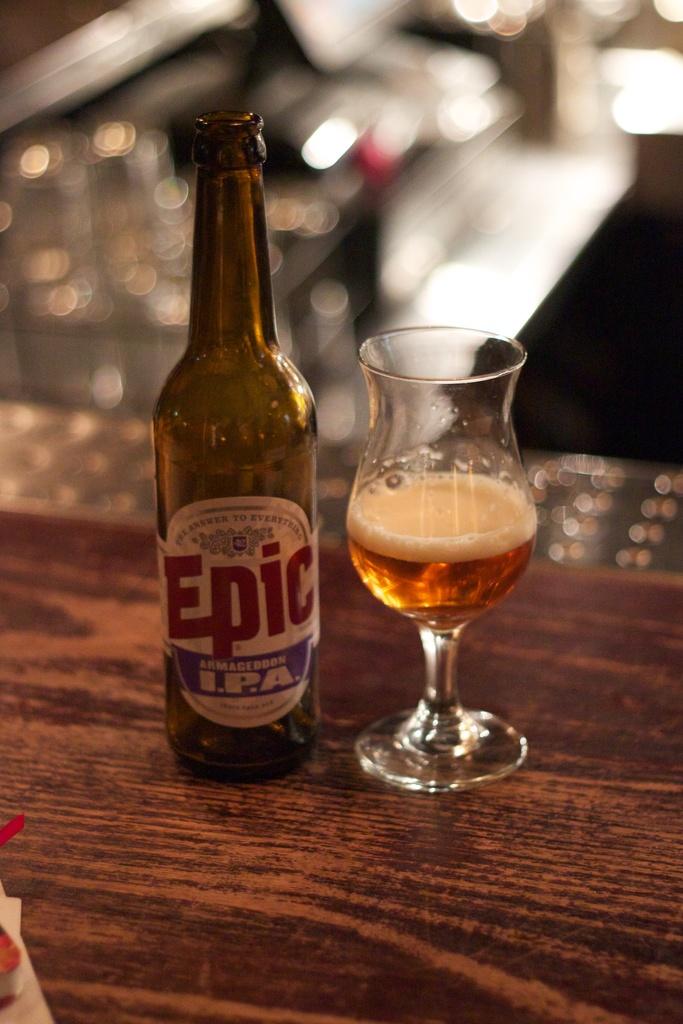Is this an ipa?
Your answer should be very brief. Yes. 